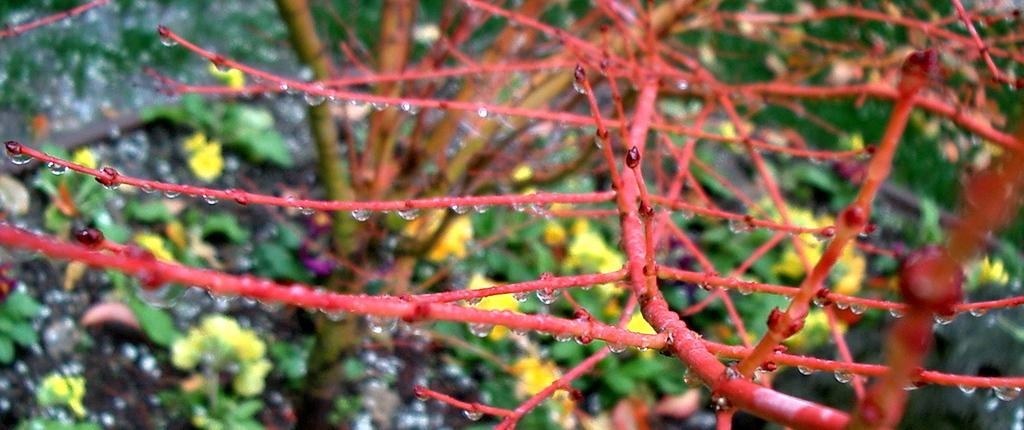How would you summarize this image in a sentence or two? As we can see in the image there are plants and yellow color flowers. 